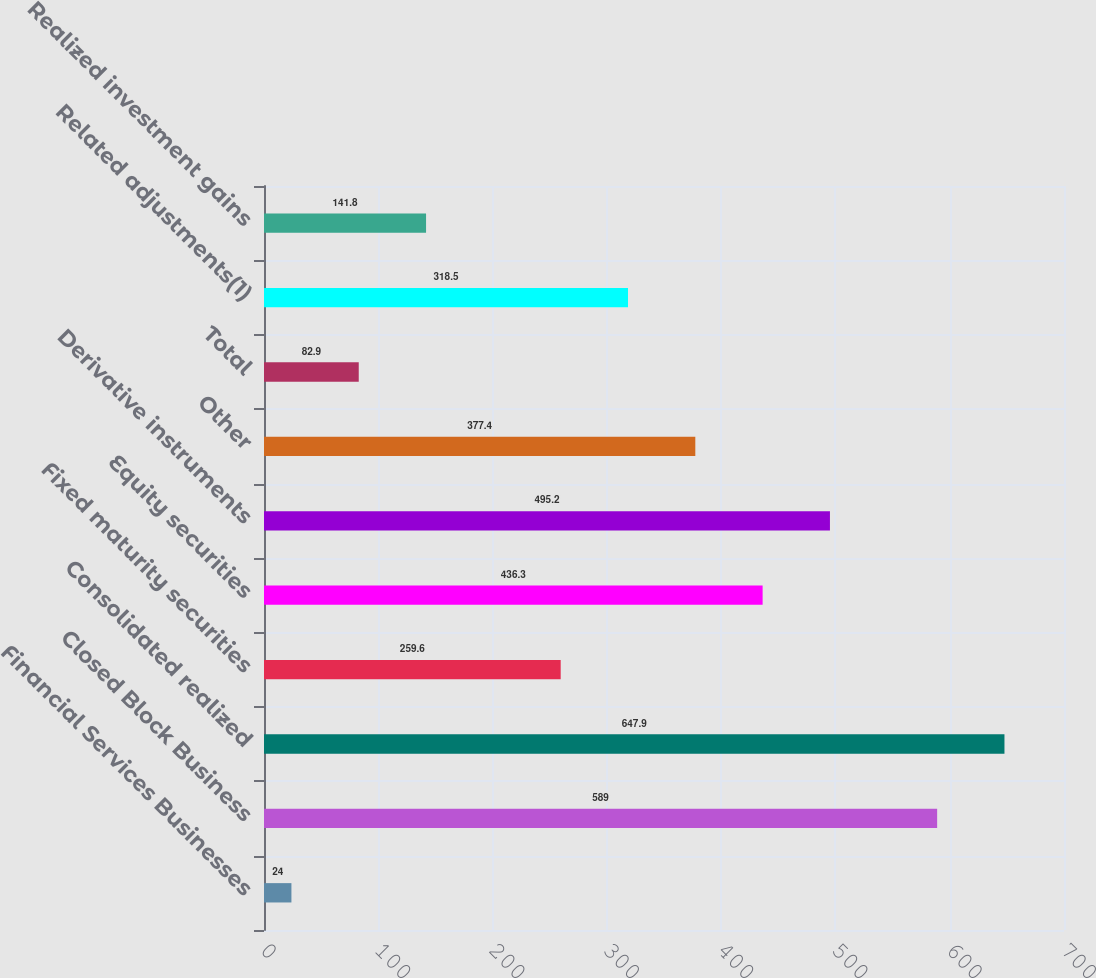Convert chart. <chart><loc_0><loc_0><loc_500><loc_500><bar_chart><fcel>Financial Services Businesses<fcel>Closed Block Business<fcel>Consolidated realized<fcel>Fixed maturity securities<fcel>Equity securities<fcel>Derivative instruments<fcel>Other<fcel>Total<fcel>Related adjustments(1)<fcel>Realized investment gains<nl><fcel>24<fcel>589<fcel>647.9<fcel>259.6<fcel>436.3<fcel>495.2<fcel>377.4<fcel>82.9<fcel>318.5<fcel>141.8<nl></chart> 